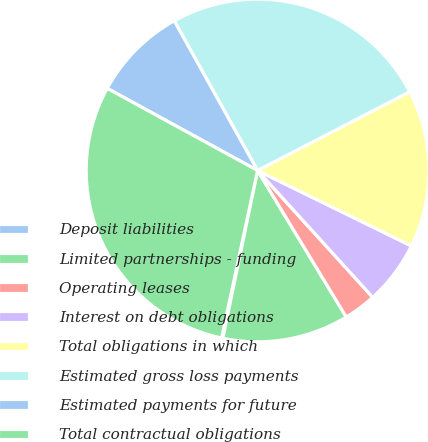<chart> <loc_0><loc_0><loc_500><loc_500><pie_chart><fcel>Deposit liabilities<fcel>Limited partnerships - funding<fcel>Operating leases<fcel>Interest on debt obligations<fcel>Total obligations in which<fcel>Estimated gross loss payments<fcel>Estimated payments for future<fcel>Total contractual obligations<nl><fcel>0.12%<fcel>11.91%<fcel>3.07%<fcel>6.01%<fcel>14.85%<fcel>25.49%<fcel>8.96%<fcel>29.59%<nl></chart> 